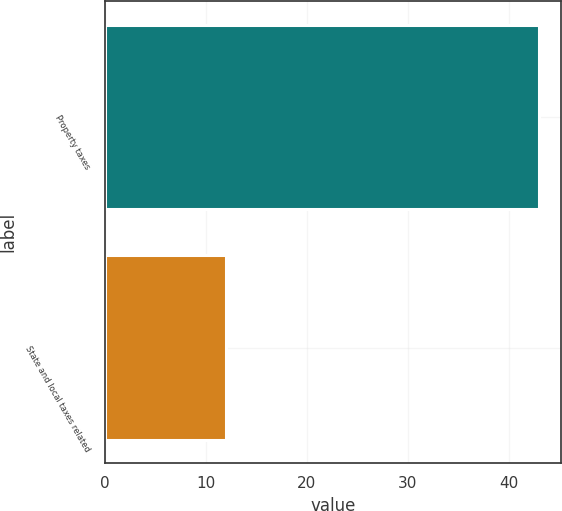Convert chart to OTSL. <chart><loc_0><loc_0><loc_500><loc_500><bar_chart><fcel>Property taxes<fcel>State and local taxes related<nl><fcel>43<fcel>12<nl></chart> 